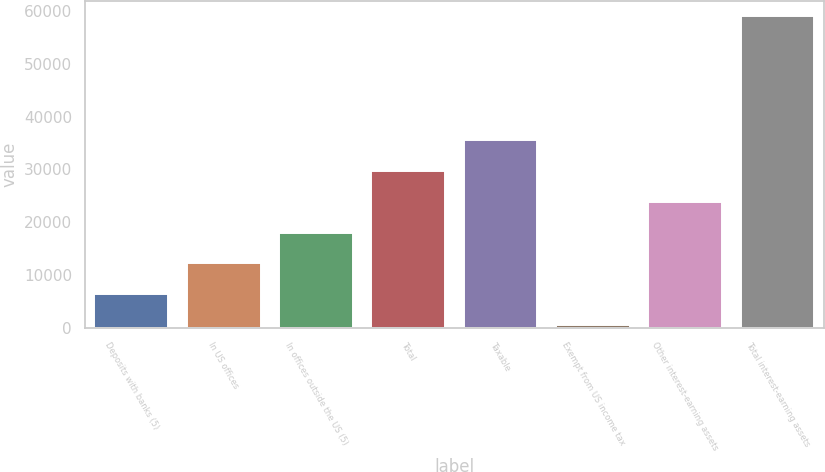Convert chart. <chart><loc_0><loc_0><loc_500><loc_500><bar_chart><fcel>Deposits with banks (5)<fcel>In US offices<fcel>In offices outside the US (5)<fcel>Total<fcel>Taxable<fcel>Exempt from US income tax<fcel>Other interest-earning assets<fcel>Total interest-earning assets<nl><fcel>6302.7<fcel>12162.4<fcel>18022.1<fcel>29741.5<fcel>35601.2<fcel>443<fcel>23881.8<fcel>59040<nl></chart> 